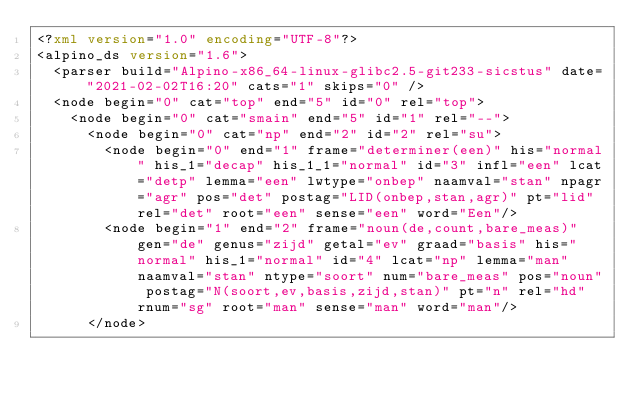<code> <loc_0><loc_0><loc_500><loc_500><_XML_><?xml version="1.0" encoding="UTF-8"?>
<alpino_ds version="1.6">
  <parser build="Alpino-x86_64-linux-glibc2.5-git233-sicstus" date="2021-02-02T16:20" cats="1" skips="0" />
  <node begin="0" cat="top" end="5" id="0" rel="top">
    <node begin="0" cat="smain" end="5" id="1" rel="--">
      <node begin="0" cat="np" end="2" id="2" rel="su">
        <node begin="0" end="1" frame="determiner(een)" his="normal" his_1="decap" his_1_1="normal" id="3" infl="een" lcat="detp" lemma="een" lwtype="onbep" naamval="stan" npagr="agr" pos="det" postag="LID(onbep,stan,agr)" pt="lid" rel="det" root="een" sense="een" word="Een"/>
        <node begin="1" end="2" frame="noun(de,count,bare_meas)" gen="de" genus="zijd" getal="ev" graad="basis" his="normal" his_1="normal" id="4" lcat="np" lemma="man" naamval="stan" ntype="soort" num="bare_meas" pos="noun" postag="N(soort,ev,basis,zijd,stan)" pt="n" rel="hd" rnum="sg" root="man" sense="man" word="man"/>
      </node></code> 